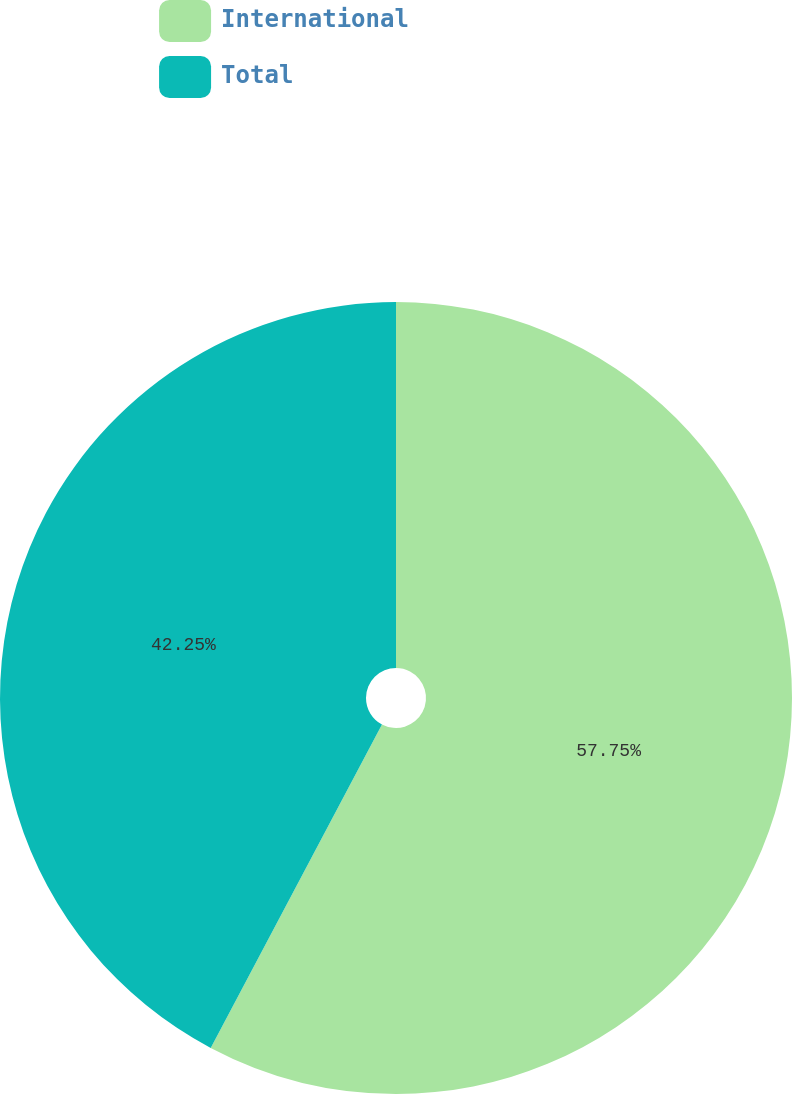Convert chart to OTSL. <chart><loc_0><loc_0><loc_500><loc_500><pie_chart><fcel>International<fcel>Total<nl><fcel>57.75%<fcel>42.25%<nl></chart> 